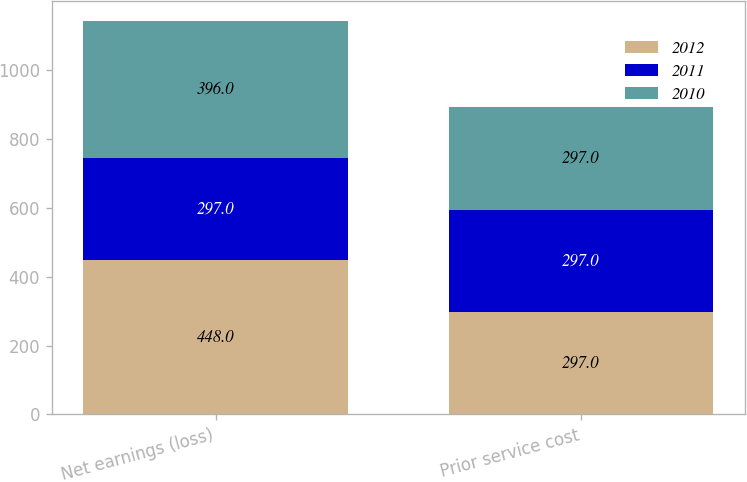<chart> <loc_0><loc_0><loc_500><loc_500><stacked_bar_chart><ecel><fcel>Net earnings (loss)<fcel>Prior service cost<nl><fcel>2012<fcel>448<fcel>297<nl><fcel>2011<fcel>297<fcel>297<nl><fcel>2010<fcel>396<fcel>297<nl></chart> 